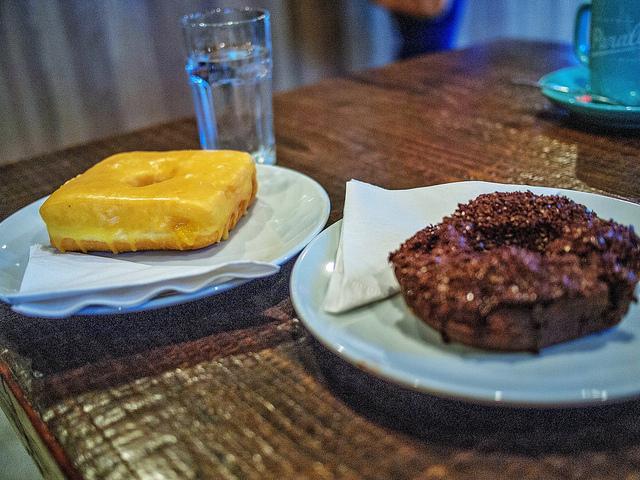Has someone started to eat the food?
Short answer required. No. Is the food a dessert or main course?
Quick response, please. Dessert. How many glasses are there?
Keep it brief. 1. 